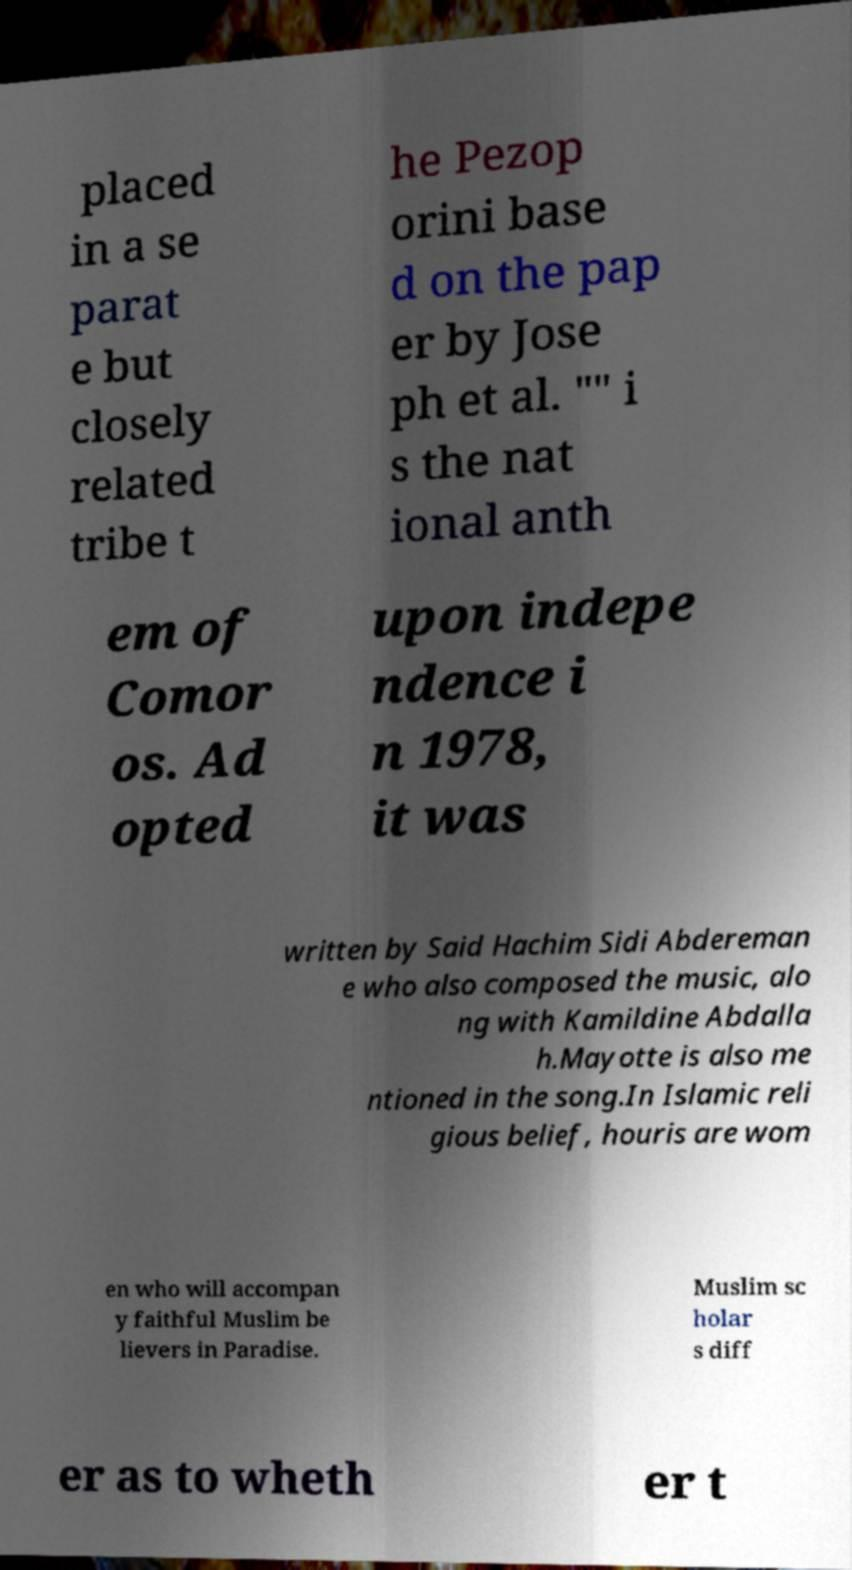For documentation purposes, I need the text within this image transcribed. Could you provide that? placed in a se parat e but closely related tribe t he Pezop orini base d on the pap er by Jose ph et al. "" i s the nat ional anth em of Comor os. Ad opted upon indepe ndence i n 1978, it was written by Said Hachim Sidi Abdereman e who also composed the music, alo ng with Kamildine Abdalla h.Mayotte is also me ntioned in the song.In Islamic reli gious belief, houris are wom en who will accompan y faithful Muslim be lievers in Paradise. Muslim sc holar s diff er as to wheth er t 